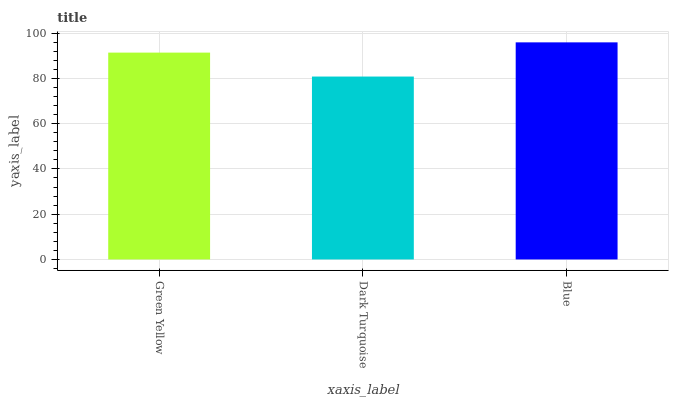Is Dark Turquoise the minimum?
Answer yes or no. Yes. Is Blue the maximum?
Answer yes or no. Yes. Is Blue the minimum?
Answer yes or no. No. Is Dark Turquoise the maximum?
Answer yes or no. No. Is Blue greater than Dark Turquoise?
Answer yes or no. Yes. Is Dark Turquoise less than Blue?
Answer yes or no. Yes. Is Dark Turquoise greater than Blue?
Answer yes or no. No. Is Blue less than Dark Turquoise?
Answer yes or no. No. Is Green Yellow the high median?
Answer yes or no. Yes. Is Green Yellow the low median?
Answer yes or no. Yes. Is Dark Turquoise the high median?
Answer yes or no. No. Is Blue the low median?
Answer yes or no. No. 